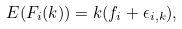<formula> <loc_0><loc_0><loc_500><loc_500>E ( F _ { i } ( k ) ) = k ( f _ { i } + \epsilon _ { i , k } ) ,</formula> 